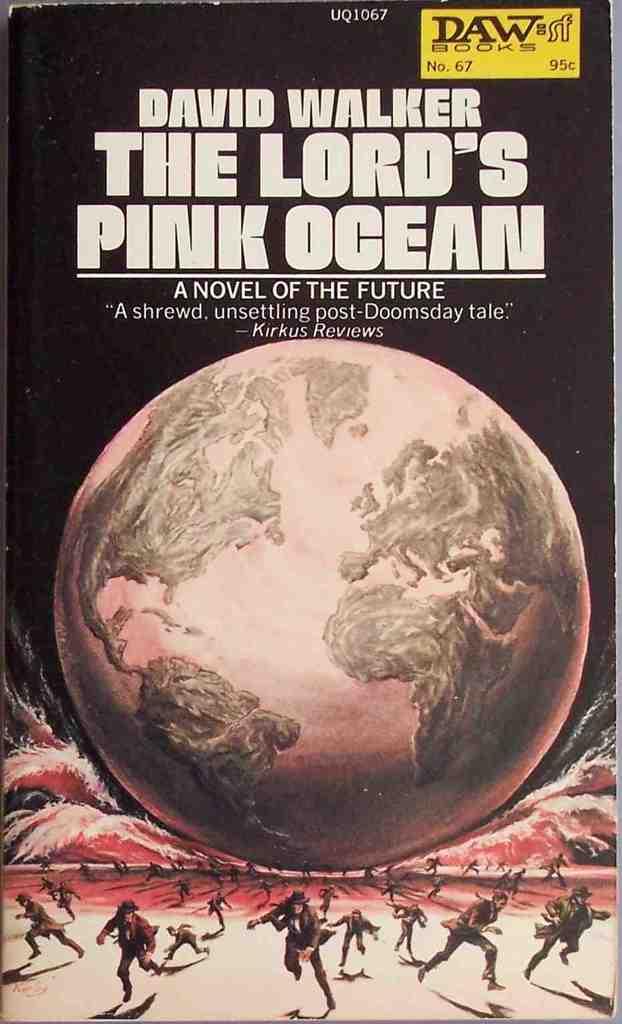What is this novel about?
Keep it short and to the point. The future. 